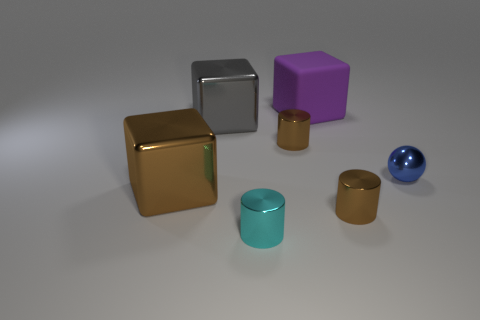How many metal objects are to the left of the purple cube and in front of the big gray cube?
Offer a terse response. 3. The small sphere is what color?
Your answer should be very brief. Blue. There is a purple object that is the same shape as the gray thing; what is it made of?
Your answer should be very brief. Rubber. Is there anything else that is made of the same material as the large purple object?
Your response must be concise. No. Is the color of the big matte object the same as the shiny sphere?
Your answer should be compact. No. There is a big shiny thing that is right of the large object that is in front of the blue metallic thing; what shape is it?
Offer a very short reply. Cube. There is a large thing that is made of the same material as the brown cube; what shape is it?
Ensure brevity in your answer.  Cube. How many other things are there of the same shape as the large purple object?
Offer a terse response. 2. There is a brown metallic cylinder that is left of the purple rubber object; is it the same size as the big gray cube?
Your answer should be very brief. No. Are there more large metal things that are in front of the cyan cylinder than red things?
Give a very brief answer. No. 